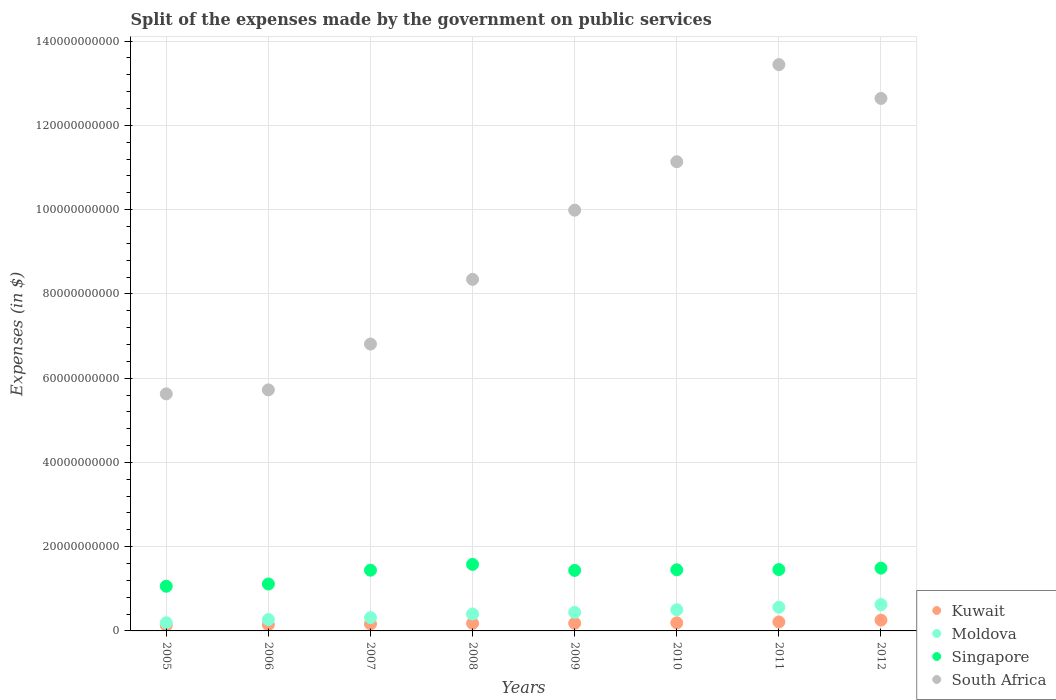Is the number of dotlines equal to the number of legend labels?
Keep it short and to the point. Yes. What is the expenses made by the government on public services in South Africa in 2005?
Provide a succinct answer. 5.63e+1. Across all years, what is the maximum expenses made by the government on public services in South Africa?
Provide a short and direct response. 1.34e+11. Across all years, what is the minimum expenses made by the government on public services in Kuwait?
Ensure brevity in your answer.  1.35e+09. In which year was the expenses made by the government on public services in Moldova maximum?
Your answer should be compact. 2012. In which year was the expenses made by the government on public services in Singapore minimum?
Offer a terse response. 2005. What is the total expenses made by the government on public services in South Africa in the graph?
Offer a very short reply. 7.37e+11. What is the difference between the expenses made by the government on public services in Moldova in 2007 and that in 2009?
Offer a very short reply. -1.26e+09. What is the difference between the expenses made by the government on public services in Kuwait in 2005 and the expenses made by the government on public services in Moldova in 2008?
Offer a very short reply. -2.67e+09. What is the average expenses made by the government on public services in Singapore per year?
Give a very brief answer. 1.38e+1. In the year 2011, what is the difference between the expenses made by the government on public services in South Africa and expenses made by the government on public services in Kuwait?
Offer a terse response. 1.32e+11. What is the ratio of the expenses made by the government on public services in South Africa in 2008 to that in 2009?
Your response must be concise. 0.84. Is the expenses made by the government on public services in Singapore in 2008 less than that in 2009?
Provide a succinct answer. No. What is the difference between the highest and the second highest expenses made by the government on public services in Moldova?
Give a very brief answer. 6.26e+08. What is the difference between the highest and the lowest expenses made by the government on public services in South Africa?
Offer a very short reply. 7.82e+1. In how many years, is the expenses made by the government on public services in Kuwait greater than the average expenses made by the government on public services in Kuwait taken over all years?
Make the answer very short. 3. Does the expenses made by the government on public services in Kuwait monotonically increase over the years?
Offer a terse response. Yes. Is the expenses made by the government on public services in Moldova strictly greater than the expenses made by the government on public services in Singapore over the years?
Offer a very short reply. No. Is the expenses made by the government on public services in Singapore strictly less than the expenses made by the government on public services in Moldova over the years?
Your answer should be compact. No. How many dotlines are there?
Offer a terse response. 4. Are the values on the major ticks of Y-axis written in scientific E-notation?
Your answer should be very brief. No. Does the graph contain any zero values?
Your answer should be compact. No. What is the title of the graph?
Provide a succinct answer. Split of the expenses made by the government on public services. Does "Cuba" appear as one of the legend labels in the graph?
Your answer should be very brief. No. What is the label or title of the X-axis?
Ensure brevity in your answer.  Years. What is the label or title of the Y-axis?
Your response must be concise. Expenses (in $). What is the Expenses (in $) in Kuwait in 2005?
Provide a succinct answer. 1.35e+09. What is the Expenses (in $) of Moldova in 2005?
Offer a very short reply. 1.94e+09. What is the Expenses (in $) in Singapore in 2005?
Provide a succinct answer. 1.06e+1. What is the Expenses (in $) of South Africa in 2005?
Give a very brief answer. 5.63e+1. What is the Expenses (in $) in Kuwait in 2006?
Your answer should be compact. 1.47e+09. What is the Expenses (in $) of Moldova in 2006?
Ensure brevity in your answer.  2.70e+09. What is the Expenses (in $) in Singapore in 2006?
Provide a short and direct response. 1.11e+1. What is the Expenses (in $) of South Africa in 2006?
Your answer should be compact. 5.72e+1. What is the Expenses (in $) in Kuwait in 2007?
Provide a short and direct response. 1.66e+09. What is the Expenses (in $) of Moldova in 2007?
Your answer should be compact. 3.15e+09. What is the Expenses (in $) in Singapore in 2007?
Make the answer very short. 1.44e+1. What is the Expenses (in $) in South Africa in 2007?
Keep it short and to the point. 6.81e+1. What is the Expenses (in $) in Kuwait in 2008?
Keep it short and to the point. 1.79e+09. What is the Expenses (in $) in Moldova in 2008?
Keep it short and to the point. 4.02e+09. What is the Expenses (in $) in Singapore in 2008?
Give a very brief answer. 1.58e+1. What is the Expenses (in $) of South Africa in 2008?
Give a very brief answer. 8.35e+1. What is the Expenses (in $) in Kuwait in 2009?
Make the answer very short. 1.82e+09. What is the Expenses (in $) in Moldova in 2009?
Your response must be concise. 4.41e+09. What is the Expenses (in $) in Singapore in 2009?
Ensure brevity in your answer.  1.44e+1. What is the Expenses (in $) in South Africa in 2009?
Provide a short and direct response. 9.99e+1. What is the Expenses (in $) of Kuwait in 2010?
Keep it short and to the point. 1.92e+09. What is the Expenses (in $) of Moldova in 2010?
Make the answer very short. 5.03e+09. What is the Expenses (in $) of Singapore in 2010?
Your response must be concise. 1.45e+1. What is the Expenses (in $) in South Africa in 2010?
Provide a succinct answer. 1.11e+11. What is the Expenses (in $) in Kuwait in 2011?
Keep it short and to the point. 2.13e+09. What is the Expenses (in $) of Moldova in 2011?
Your answer should be compact. 5.63e+09. What is the Expenses (in $) of Singapore in 2011?
Your response must be concise. 1.46e+1. What is the Expenses (in $) in South Africa in 2011?
Provide a succinct answer. 1.34e+11. What is the Expenses (in $) of Kuwait in 2012?
Your response must be concise. 2.56e+09. What is the Expenses (in $) in Moldova in 2012?
Make the answer very short. 6.25e+09. What is the Expenses (in $) of Singapore in 2012?
Provide a short and direct response. 1.49e+1. What is the Expenses (in $) in South Africa in 2012?
Offer a terse response. 1.26e+11. Across all years, what is the maximum Expenses (in $) in Kuwait?
Provide a succinct answer. 2.56e+09. Across all years, what is the maximum Expenses (in $) of Moldova?
Offer a very short reply. 6.25e+09. Across all years, what is the maximum Expenses (in $) of Singapore?
Provide a short and direct response. 1.58e+1. Across all years, what is the maximum Expenses (in $) of South Africa?
Your response must be concise. 1.34e+11. Across all years, what is the minimum Expenses (in $) in Kuwait?
Your answer should be very brief. 1.35e+09. Across all years, what is the minimum Expenses (in $) of Moldova?
Offer a very short reply. 1.94e+09. Across all years, what is the minimum Expenses (in $) of Singapore?
Provide a short and direct response. 1.06e+1. Across all years, what is the minimum Expenses (in $) of South Africa?
Keep it short and to the point. 5.63e+1. What is the total Expenses (in $) in Kuwait in the graph?
Give a very brief answer. 1.47e+1. What is the total Expenses (in $) in Moldova in the graph?
Your response must be concise. 3.31e+1. What is the total Expenses (in $) of Singapore in the graph?
Your answer should be very brief. 1.10e+11. What is the total Expenses (in $) of South Africa in the graph?
Offer a very short reply. 7.37e+11. What is the difference between the Expenses (in $) in Kuwait in 2005 and that in 2006?
Make the answer very short. -1.22e+08. What is the difference between the Expenses (in $) in Moldova in 2005 and that in 2006?
Offer a terse response. -7.68e+08. What is the difference between the Expenses (in $) in Singapore in 2005 and that in 2006?
Make the answer very short. -5.39e+08. What is the difference between the Expenses (in $) in South Africa in 2005 and that in 2006?
Provide a short and direct response. -9.39e+08. What is the difference between the Expenses (in $) of Kuwait in 2005 and that in 2007?
Your response must be concise. -3.08e+08. What is the difference between the Expenses (in $) of Moldova in 2005 and that in 2007?
Ensure brevity in your answer.  -1.21e+09. What is the difference between the Expenses (in $) in Singapore in 2005 and that in 2007?
Provide a short and direct response. -3.81e+09. What is the difference between the Expenses (in $) of South Africa in 2005 and that in 2007?
Your response must be concise. -1.18e+1. What is the difference between the Expenses (in $) in Kuwait in 2005 and that in 2008?
Offer a terse response. -4.40e+08. What is the difference between the Expenses (in $) in Moldova in 2005 and that in 2008?
Your answer should be very brief. -2.08e+09. What is the difference between the Expenses (in $) of Singapore in 2005 and that in 2008?
Ensure brevity in your answer.  -5.19e+09. What is the difference between the Expenses (in $) in South Africa in 2005 and that in 2008?
Give a very brief answer. -2.72e+1. What is the difference between the Expenses (in $) of Kuwait in 2005 and that in 2009?
Keep it short and to the point. -4.72e+08. What is the difference between the Expenses (in $) in Moldova in 2005 and that in 2009?
Your response must be concise. -2.47e+09. What is the difference between the Expenses (in $) of Singapore in 2005 and that in 2009?
Your answer should be compact. -3.76e+09. What is the difference between the Expenses (in $) in South Africa in 2005 and that in 2009?
Make the answer very short. -4.36e+1. What is the difference between the Expenses (in $) in Kuwait in 2005 and that in 2010?
Keep it short and to the point. -5.70e+08. What is the difference between the Expenses (in $) in Moldova in 2005 and that in 2010?
Offer a very short reply. -3.10e+09. What is the difference between the Expenses (in $) of Singapore in 2005 and that in 2010?
Make the answer very short. -3.91e+09. What is the difference between the Expenses (in $) in South Africa in 2005 and that in 2010?
Your answer should be compact. -5.51e+1. What is the difference between the Expenses (in $) of Kuwait in 2005 and that in 2011?
Your answer should be very brief. -7.79e+08. What is the difference between the Expenses (in $) of Moldova in 2005 and that in 2011?
Your answer should be very brief. -3.69e+09. What is the difference between the Expenses (in $) in Singapore in 2005 and that in 2011?
Ensure brevity in your answer.  -3.96e+09. What is the difference between the Expenses (in $) of South Africa in 2005 and that in 2011?
Give a very brief answer. -7.82e+1. What is the difference between the Expenses (in $) in Kuwait in 2005 and that in 2012?
Offer a very short reply. -1.21e+09. What is the difference between the Expenses (in $) of Moldova in 2005 and that in 2012?
Give a very brief answer. -4.32e+09. What is the difference between the Expenses (in $) in Singapore in 2005 and that in 2012?
Keep it short and to the point. -4.30e+09. What is the difference between the Expenses (in $) in South Africa in 2005 and that in 2012?
Keep it short and to the point. -7.01e+1. What is the difference between the Expenses (in $) of Kuwait in 2006 and that in 2007?
Provide a short and direct response. -1.86e+08. What is the difference between the Expenses (in $) in Moldova in 2006 and that in 2007?
Offer a terse response. -4.45e+08. What is the difference between the Expenses (in $) of Singapore in 2006 and that in 2007?
Offer a very short reply. -3.27e+09. What is the difference between the Expenses (in $) in South Africa in 2006 and that in 2007?
Provide a short and direct response. -1.09e+1. What is the difference between the Expenses (in $) in Kuwait in 2006 and that in 2008?
Ensure brevity in your answer.  -3.18e+08. What is the difference between the Expenses (in $) in Moldova in 2006 and that in 2008?
Offer a terse response. -1.31e+09. What is the difference between the Expenses (in $) in Singapore in 2006 and that in 2008?
Your answer should be very brief. -4.65e+09. What is the difference between the Expenses (in $) in South Africa in 2006 and that in 2008?
Provide a succinct answer. -2.62e+1. What is the difference between the Expenses (in $) of Kuwait in 2006 and that in 2009?
Provide a succinct answer. -3.50e+08. What is the difference between the Expenses (in $) in Moldova in 2006 and that in 2009?
Provide a short and direct response. -1.70e+09. What is the difference between the Expenses (in $) in Singapore in 2006 and that in 2009?
Make the answer very short. -3.22e+09. What is the difference between the Expenses (in $) in South Africa in 2006 and that in 2009?
Your response must be concise. -4.27e+1. What is the difference between the Expenses (in $) of Kuwait in 2006 and that in 2010?
Give a very brief answer. -4.48e+08. What is the difference between the Expenses (in $) in Moldova in 2006 and that in 2010?
Offer a terse response. -2.33e+09. What is the difference between the Expenses (in $) in Singapore in 2006 and that in 2010?
Give a very brief answer. -3.37e+09. What is the difference between the Expenses (in $) in South Africa in 2006 and that in 2010?
Give a very brief answer. -5.42e+1. What is the difference between the Expenses (in $) in Kuwait in 2006 and that in 2011?
Provide a short and direct response. -6.57e+08. What is the difference between the Expenses (in $) of Moldova in 2006 and that in 2011?
Give a very brief answer. -2.92e+09. What is the difference between the Expenses (in $) of Singapore in 2006 and that in 2011?
Your answer should be very brief. -3.42e+09. What is the difference between the Expenses (in $) of South Africa in 2006 and that in 2011?
Offer a very short reply. -7.72e+1. What is the difference between the Expenses (in $) of Kuwait in 2006 and that in 2012?
Keep it short and to the point. -1.09e+09. What is the difference between the Expenses (in $) in Moldova in 2006 and that in 2012?
Your response must be concise. -3.55e+09. What is the difference between the Expenses (in $) in Singapore in 2006 and that in 2012?
Offer a very short reply. -3.76e+09. What is the difference between the Expenses (in $) of South Africa in 2006 and that in 2012?
Your answer should be compact. -6.92e+1. What is the difference between the Expenses (in $) in Kuwait in 2007 and that in 2008?
Make the answer very short. -1.32e+08. What is the difference between the Expenses (in $) in Moldova in 2007 and that in 2008?
Offer a terse response. -8.67e+08. What is the difference between the Expenses (in $) in Singapore in 2007 and that in 2008?
Provide a short and direct response. -1.38e+09. What is the difference between the Expenses (in $) of South Africa in 2007 and that in 2008?
Ensure brevity in your answer.  -1.54e+1. What is the difference between the Expenses (in $) in Kuwait in 2007 and that in 2009?
Provide a succinct answer. -1.64e+08. What is the difference between the Expenses (in $) of Moldova in 2007 and that in 2009?
Make the answer very short. -1.26e+09. What is the difference between the Expenses (in $) of Singapore in 2007 and that in 2009?
Offer a very short reply. 4.70e+07. What is the difference between the Expenses (in $) in South Africa in 2007 and that in 2009?
Ensure brevity in your answer.  -3.18e+1. What is the difference between the Expenses (in $) of Kuwait in 2007 and that in 2010?
Your answer should be compact. -2.62e+08. What is the difference between the Expenses (in $) in Moldova in 2007 and that in 2010?
Keep it short and to the point. -1.88e+09. What is the difference between the Expenses (in $) in Singapore in 2007 and that in 2010?
Offer a very short reply. -9.78e+07. What is the difference between the Expenses (in $) in South Africa in 2007 and that in 2010?
Make the answer very short. -4.33e+1. What is the difference between the Expenses (in $) in Kuwait in 2007 and that in 2011?
Offer a terse response. -4.71e+08. What is the difference between the Expenses (in $) in Moldova in 2007 and that in 2011?
Your response must be concise. -2.48e+09. What is the difference between the Expenses (in $) of Singapore in 2007 and that in 2011?
Give a very brief answer. -1.50e+08. What is the difference between the Expenses (in $) of South Africa in 2007 and that in 2011?
Give a very brief answer. -6.63e+1. What is the difference between the Expenses (in $) in Kuwait in 2007 and that in 2012?
Give a very brief answer. -9.04e+08. What is the difference between the Expenses (in $) in Moldova in 2007 and that in 2012?
Provide a short and direct response. -3.10e+09. What is the difference between the Expenses (in $) in Singapore in 2007 and that in 2012?
Ensure brevity in your answer.  -4.86e+08. What is the difference between the Expenses (in $) in South Africa in 2007 and that in 2012?
Your answer should be compact. -5.83e+1. What is the difference between the Expenses (in $) in Kuwait in 2008 and that in 2009?
Make the answer very short. -3.20e+07. What is the difference between the Expenses (in $) of Moldova in 2008 and that in 2009?
Offer a very short reply. -3.88e+08. What is the difference between the Expenses (in $) in Singapore in 2008 and that in 2009?
Your response must be concise. 1.42e+09. What is the difference between the Expenses (in $) in South Africa in 2008 and that in 2009?
Provide a succinct answer. -1.64e+1. What is the difference between the Expenses (in $) in Kuwait in 2008 and that in 2010?
Give a very brief answer. -1.30e+08. What is the difference between the Expenses (in $) of Moldova in 2008 and that in 2010?
Keep it short and to the point. -1.02e+09. What is the difference between the Expenses (in $) in Singapore in 2008 and that in 2010?
Provide a short and direct response. 1.28e+09. What is the difference between the Expenses (in $) of South Africa in 2008 and that in 2010?
Give a very brief answer. -2.79e+1. What is the difference between the Expenses (in $) of Kuwait in 2008 and that in 2011?
Your answer should be very brief. -3.39e+08. What is the difference between the Expenses (in $) of Moldova in 2008 and that in 2011?
Provide a succinct answer. -1.61e+09. What is the difference between the Expenses (in $) of Singapore in 2008 and that in 2011?
Keep it short and to the point. 1.23e+09. What is the difference between the Expenses (in $) of South Africa in 2008 and that in 2011?
Give a very brief answer. -5.10e+1. What is the difference between the Expenses (in $) of Kuwait in 2008 and that in 2012?
Ensure brevity in your answer.  -7.72e+08. What is the difference between the Expenses (in $) in Moldova in 2008 and that in 2012?
Make the answer very short. -2.24e+09. What is the difference between the Expenses (in $) of Singapore in 2008 and that in 2012?
Your response must be concise. 8.91e+08. What is the difference between the Expenses (in $) in South Africa in 2008 and that in 2012?
Give a very brief answer. -4.29e+1. What is the difference between the Expenses (in $) in Kuwait in 2009 and that in 2010?
Give a very brief answer. -9.80e+07. What is the difference between the Expenses (in $) in Moldova in 2009 and that in 2010?
Your response must be concise. -6.28e+08. What is the difference between the Expenses (in $) in Singapore in 2009 and that in 2010?
Keep it short and to the point. -1.45e+08. What is the difference between the Expenses (in $) of South Africa in 2009 and that in 2010?
Your response must be concise. -1.15e+1. What is the difference between the Expenses (in $) in Kuwait in 2009 and that in 2011?
Offer a terse response. -3.07e+08. What is the difference between the Expenses (in $) in Moldova in 2009 and that in 2011?
Keep it short and to the point. -1.22e+09. What is the difference between the Expenses (in $) of Singapore in 2009 and that in 2011?
Offer a very short reply. -1.97e+08. What is the difference between the Expenses (in $) in South Africa in 2009 and that in 2011?
Provide a succinct answer. -3.46e+1. What is the difference between the Expenses (in $) of Kuwait in 2009 and that in 2012?
Make the answer very short. -7.40e+08. What is the difference between the Expenses (in $) in Moldova in 2009 and that in 2012?
Provide a short and direct response. -1.85e+09. What is the difference between the Expenses (in $) of Singapore in 2009 and that in 2012?
Your answer should be very brief. -5.33e+08. What is the difference between the Expenses (in $) in South Africa in 2009 and that in 2012?
Provide a short and direct response. -2.65e+1. What is the difference between the Expenses (in $) in Kuwait in 2010 and that in 2011?
Your response must be concise. -2.09e+08. What is the difference between the Expenses (in $) in Moldova in 2010 and that in 2011?
Your answer should be very brief. -5.93e+08. What is the difference between the Expenses (in $) of Singapore in 2010 and that in 2011?
Keep it short and to the point. -5.24e+07. What is the difference between the Expenses (in $) in South Africa in 2010 and that in 2011?
Provide a succinct answer. -2.31e+1. What is the difference between the Expenses (in $) of Kuwait in 2010 and that in 2012?
Ensure brevity in your answer.  -6.42e+08. What is the difference between the Expenses (in $) in Moldova in 2010 and that in 2012?
Keep it short and to the point. -1.22e+09. What is the difference between the Expenses (in $) of Singapore in 2010 and that in 2012?
Provide a succinct answer. -3.88e+08. What is the difference between the Expenses (in $) of South Africa in 2010 and that in 2012?
Your answer should be very brief. -1.50e+1. What is the difference between the Expenses (in $) in Kuwait in 2011 and that in 2012?
Offer a terse response. -4.33e+08. What is the difference between the Expenses (in $) of Moldova in 2011 and that in 2012?
Your answer should be compact. -6.26e+08. What is the difference between the Expenses (in $) of Singapore in 2011 and that in 2012?
Make the answer very short. -3.36e+08. What is the difference between the Expenses (in $) of South Africa in 2011 and that in 2012?
Provide a short and direct response. 8.03e+09. What is the difference between the Expenses (in $) of Kuwait in 2005 and the Expenses (in $) of Moldova in 2006?
Your answer should be very brief. -1.35e+09. What is the difference between the Expenses (in $) in Kuwait in 2005 and the Expenses (in $) in Singapore in 2006?
Offer a very short reply. -9.79e+09. What is the difference between the Expenses (in $) in Kuwait in 2005 and the Expenses (in $) in South Africa in 2006?
Your response must be concise. -5.59e+1. What is the difference between the Expenses (in $) in Moldova in 2005 and the Expenses (in $) in Singapore in 2006?
Give a very brief answer. -9.21e+09. What is the difference between the Expenses (in $) in Moldova in 2005 and the Expenses (in $) in South Africa in 2006?
Make the answer very short. -5.53e+1. What is the difference between the Expenses (in $) in Singapore in 2005 and the Expenses (in $) in South Africa in 2006?
Ensure brevity in your answer.  -4.66e+1. What is the difference between the Expenses (in $) in Kuwait in 2005 and the Expenses (in $) in Moldova in 2007?
Keep it short and to the point. -1.80e+09. What is the difference between the Expenses (in $) of Kuwait in 2005 and the Expenses (in $) of Singapore in 2007?
Your answer should be very brief. -1.31e+1. What is the difference between the Expenses (in $) in Kuwait in 2005 and the Expenses (in $) in South Africa in 2007?
Offer a terse response. -6.67e+1. What is the difference between the Expenses (in $) in Moldova in 2005 and the Expenses (in $) in Singapore in 2007?
Your response must be concise. -1.25e+1. What is the difference between the Expenses (in $) of Moldova in 2005 and the Expenses (in $) of South Africa in 2007?
Your answer should be compact. -6.62e+1. What is the difference between the Expenses (in $) in Singapore in 2005 and the Expenses (in $) in South Africa in 2007?
Provide a short and direct response. -5.75e+1. What is the difference between the Expenses (in $) of Kuwait in 2005 and the Expenses (in $) of Moldova in 2008?
Your response must be concise. -2.67e+09. What is the difference between the Expenses (in $) in Kuwait in 2005 and the Expenses (in $) in Singapore in 2008?
Provide a short and direct response. -1.44e+1. What is the difference between the Expenses (in $) in Kuwait in 2005 and the Expenses (in $) in South Africa in 2008?
Your answer should be compact. -8.21e+1. What is the difference between the Expenses (in $) in Moldova in 2005 and the Expenses (in $) in Singapore in 2008?
Provide a succinct answer. -1.39e+1. What is the difference between the Expenses (in $) of Moldova in 2005 and the Expenses (in $) of South Africa in 2008?
Provide a succinct answer. -8.15e+1. What is the difference between the Expenses (in $) of Singapore in 2005 and the Expenses (in $) of South Africa in 2008?
Ensure brevity in your answer.  -7.29e+1. What is the difference between the Expenses (in $) of Kuwait in 2005 and the Expenses (in $) of Moldova in 2009?
Give a very brief answer. -3.05e+09. What is the difference between the Expenses (in $) of Kuwait in 2005 and the Expenses (in $) of Singapore in 2009?
Provide a succinct answer. -1.30e+1. What is the difference between the Expenses (in $) of Kuwait in 2005 and the Expenses (in $) of South Africa in 2009?
Your response must be concise. -9.85e+1. What is the difference between the Expenses (in $) in Moldova in 2005 and the Expenses (in $) in Singapore in 2009?
Offer a terse response. -1.24e+1. What is the difference between the Expenses (in $) of Moldova in 2005 and the Expenses (in $) of South Africa in 2009?
Provide a short and direct response. -9.79e+1. What is the difference between the Expenses (in $) of Singapore in 2005 and the Expenses (in $) of South Africa in 2009?
Make the answer very short. -8.93e+1. What is the difference between the Expenses (in $) of Kuwait in 2005 and the Expenses (in $) of Moldova in 2010?
Offer a very short reply. -3.68e+09. What is the difference between the Expenses (in $) of Kuwait in 2005 and the Expenses (in $) of Singapore in 2010?
Your answer should be compact. -1.32e+1. What is the difference between the Expenses (in $) in Kuwait in 2005 and the Expenses (in $) in South Africa in 2010?
Ensure brevity in your answer.  -1.10e+11. What is the difference between the Expenses (in $) of Moldova in 2005 and the Expenses (in $) of Singapore in 2010?
Give a very brief answer. -1.26e+1. What is the difference between the Expenses (in $) of Moldova in 2005 and the Expenses (in $) of South Africa in 2010?
Make the answer very short. -1.09e+11. What is the difference between the Expenses (in $) in Singapore in 2005 and the Expenses (in $) in South Africa in 2010?
Make the answer very short. -1.01e+11. What is the difference between the Expenses (in $) of Kuwait in 2005 and the Expenses (in $) of Moldova in 2011?
Give a very brief answer. -4.28e+09. What is the difference between the Expenses (in $) of Kuwait in 2005 and the Expenses (in $) of Singapore in 2011?
Ensure brevity in your answer.  -1.32e+1. What is the difference between the Expenses (in $) in Kuwait in 2005 and the Expenses (in $) in South Africa in 2011?
Give a very brief answer. -1.33e+11. What is the difference between the Expenses (in $) in Moldova in 2005 and the Expenses (in $) in Singapore in 2011?
Make the answer very short. -1.26e+1. What is the difference between the Expenses (in $) in Moldova in 2005 and the Expenses (in $) in South Africa in 2011?
Offer a terse response. -1.32e+11. What is the difference between the Expenses (in $) of Singapore in 2005 and the Expenses (in $) of South Africa in 2011?
Provide a succinct answer. -1.24e+11. What is the difference between the Expenses (in $) in Kuwait in 2005 and the Expenses (in $) in Moldova in 2012?
Keep it short and to the point. -4.90e+09. What is the difference between the Expenses (in $) of Kuwait in 2005 and the Expenses (in $) of Singapore in 2012?
Give a very brief answer. -1.35e+1. What is the difference between the Expenses (in $) in Kuwait in 2005 and the Expenses (in $) in South Africa in 2012?
Ensure brevity in your answer.  -1.25e+11. What is the difference between the Expenses (in $) of Moldova in 2005 and the Expenses (in $) of Singapore in 2012?
Your response must be concise. -1.30e+1. What is the difference between the Expenses (in $) of Moldova in 2005 and the Expenses (in $) of South Africa in 2012?
Give a very brief answer. -1.24e+11. What is the difference between the Expenses (in $) in Singapore in 2005 and the Expenses (in $) in South Africa in 2012?
Make the answer very short. -1.16e+11. What is the difference between the Expenses (in $) in Kuwait in 2006 and the Expenses (in $) in Moldova in 2007?
Offer a very short reply. -1.68e+09. What is the difference between the Expenses (in $) of Kuwait in 2006 and the Expenses (in $) of Singapore in 2007?
Your answer should be very brief. -1.29e+1. What is the difference between the Expenses (in $) in Kuwait in 2006 and the Expenses (in $) in South Africa in 2007?
Offer a very short reply. -6.66e+1. What is the difference between the Expenses (in $) of Moldova in 2006 and the Expenses (in $) of Singapore in 2007?
Offer a terse response. -1.17e+1. What is the difference between the Expenses (in $) in Moldova in 2006 and the Expenses (in $) in South Africa in 2007?
Offer a very short reply. -6.54e+1. What is the difference between the Expenses (in $) in Singapore in 2006 and the Expenses (in $) in South Africa in 2007?
Your answer should be compact. -5.70e+1. What is the difference between the Expenses (in $) of Kuwait in 2006 and the Expenses (in $) of Moldova in 2008?
Give a very brief answer. -2.54e+09. What is the difference between the Expenses (in $) of Kuwait in 2006 and the Expenses (in $) of Singapore in 2008?
Your response must be concise. -1.43e+1. What is the difference between the Expenses (in $) of Kuwait in 2006 and the Expenses (in $) of South Africa in 2008?
Give a very brief answer. -8.20e+1. What is the difference between the Expenses (in $) of Moldova in 2006 and the Expenses (in $) of Singapore in 2008?
Your answer should be compact. -1.31e+1. What is the difference between the Expenses (in $) in Moldova in 2006 and the Expenses (in $) in South Africa in 2008?
Give a very brief answer. -8.08e+1. What is the difference between the Expenses (in $) of Singapore in 2006 and the Expenses (in $) of South Africa in 2008?
Provide a succinct answer. -7.23e+1. What is the difference between the Expenses (in $) of Kuwait in 2006 and the Expenses (in $) of Moldova in 2009?
Offer a very short reply. -2.93e+09. What is the difference between the Expenses (in $) in Kuwait in 2006 and the Expenses (in $) in Singapore in 2009?
Your answer should be compact. -1.29e+1. What is the difference between the Expenses (in $) of Kuwait in 2006 and the Expenses (in $) of South Africa in 2009?
Keep it short and to the point. -9.84e+1. What is the difference between the Expenses (in $) in Moldova in 2006 and the Expenses (in $) in Singapore in 2009?
Offer a very short reply. -1.17e+1. What is the difference between the Expenses (in $) in Moldova in 2006 and the Expenses (in $) in South Africa in 2009?
Your response must be concise. -9.72e+1. What is the difference between the Expenses (in $) of Singapore in 2006 and the Expenses (in $) of South Africa in 2009?
Ensure brevity in your answer.  -8.87e+1. What is the difference between the Expenses (in $) of Kuwait in 2006 and the Expenses (in $) of Moldova in 2010?
Provide a short and direct response. -3.56e+09. What is the difference between the Expenses (in $) of Kuwait in 2006 and the Expenses (in $) of Singapore in 2010?
Offer a very short reply. -1.30e+1. What is the difference between the Expenses (in $) of Kuwait in 2006 and the Expenses (in $) of South Africa in 2010?
Provide a succinct answer. -1.10e+11. What is the difference between the Expenses (in $) in Moldova in 2006 and the Expenses (in $) in Singapore in 2010?
Your answer should be very brief. -1.18e+1. What is the difference between the Expenses (in $) of Moldova in 2006 and the Expenses (in $) of South Africa in 2010?
Your answer should be compact. -1.09e+11. What is the difference between the Expenses (in $) in Singapore in 2006 and the Expenses (in $) in South Africa in 2010?
Ensure brevity in your answer.  -1.00e+11. What is the difference between the Expenses (in $) in Kuwait in 2006 and the Expenses (in $) in Moldova in 2011?
Your answer should be compact. -4.15e+09. What is the difference between the Expenses (in $) in Kuwait in 2006 and the Expenses (in $) in Singapore in 2011?
Provide a succinct answer. -1.31e+1. What is the difference between the Expenses (in $) in Kuwait in 2006 and the Expenses (in $) in South Africa in 2011?
Offer a very short reply. -1.33e+11. What is the difference between the Expenses (in $) of Moldova in 2006 and the Expenses (in $) of Singapore in 2011?
Make the answer very short. -1.19e+1. What is the difference between the Expenses (in $) of Moldova in 2006 and the Expenses (in $) of South Africa in 2011?
Provide a short and direct response. -1.32e+11. What is the difference between the Expenses (in $) in Singapore in 2006 and the Expenses (in $) in South Africa in 2011?
Offer a terse response. -1.23e+11. What is the difference between the Expenses (in $) in Kuwait in 2006 and the Expenses (in $) in Moldova in 2012?
Your answer should be very brief. -4.78e+09. What is the difference between the Expenses (in $) of Kuwait in 2006 and the Expenses (in $) of Singapore in 2012?
Make the answer very short. -1.34e+1. What is the difference between the Expenses (in $) in Kuwait in 2006 and the Expenses (in $) in South Africa in 2012?
Your answer should be very brief. -1.25e+11. What is the difference between the Expenses (in $) of Moldova in 2006 and the Expenses (in $) of Singapore in 2012?
Provide a short and direct response. -1.22e+1. What is the difference between the Expenses (in $) of Moldova in 2006 and the Expenses (in $) of South Africa in 2012?
Provide a short and direct response. -1.24e+11. What is the difference between the Expenses (in $) of Singapore in 2006 and the Expenses (in $) of South Africa in 2012?
Ensure brevity in your answer.  -1.15e+11. What is the difference between the Expenses (in $) in Kuwait in 2007 and the Expenses (in $) in Moldova in 2008?
Offer a very short reply. -2.36e+09. What is the difference between the Expenses (in $) in Kuwait in 2007 and the Expenses (in $) in Singapore in 2008?
Your response must be concise. -1.41e+1. What is the difference between the Expenses (in $) in Kuwait in 2007 and the Expenses (in $) in South Africa in 2008?
Make the answer very short. -8.18e+1. What is the difference between the Expenses (in $) in Moldova in 2007 and the Expenses (in $) in Singapore in 2008?
Provide a short and direct response. -1.26e+1. What is the difference between the Expenses (in $) of Moldova in 2007 and the Expenses (in $) of South Africa in 2008?
Provide a succinct answer. -8.03e+1. What is the difference between the Expenses (in $) in Singapore in 2007 and the Expenses (in $) in South Africa in 2008?
Offer a terse response. -6.90e+1. What is the difference between the Expenses (in $) in Kuwait in 2007 and the Expenses (in $) in Moldova in 2009?
Provide a short and direct response. -2.75e+09. What is the difference between the Expenses (in $) in Kuwait in 2007 and the Expenses (in $) in Singapore in 2009?
Make the answer very short. -1.27e+1. What is the difference between the Expenses (in $) of Kuwait in 2007 and the Expenses (in $) of South Africa in 2009?
Provide a short and direct response. -9.82e+1. What is the difference between the Expenses (in $) in Moldova in 2007 and the Expenses (in $) in Singapore in 2009?
Your answer should be compact. -1.12e+1. What is the difference between the Expenses (in $) in Moldova in 2007 and the Expenses (in $) in South Africa in 2009?
Offer a terse response. -9.67e+1. What is the difference between the Expenses (in $) of Singapore in 2007 and the Expenses (in $) of South Africa in 2009?
Your answer should be very brief. -8.55e+1. What is the difference between the Expenses (in $) of Kuwait in 2007 and the Expenses (in $) of Moldova in 2010?
Your answer should be compact. -3.37e+09. What is the difference between the Expenses (in $) of Kuwait in 2007 and the Expenses (in $) of Singapore in 2010?
Provide a succinct answer. -1.29e+1. What is the difference between the Expenses (in $) in Kuwait in 2007 and the Expenses (in $) in South Africa in 2010?
Offer a very short reply. -1.10e+11. What is the difference between the Expenses (in $) of Moldova in 2007 and the Expenses (in $) of Singapore in 2010?
Make the answer very short. -1.14e+1. What is the difference between the Expenses (in $) of Moldova in 2007 and the Expenses (in $) of South Africa in 2010?
Your answer should be compact. -1.08e+11. What is the difference between the Expenses (in $) of Singapore in 2007 and the Expenses (in $) of South Africa in 2010?
Keep it short and to the point. -9.70e+1. What is the difference between the Expenses (in $) of Kuwait in 2007 and the Expenses (in $) of Moldova in 2011?
Keep it short and to the point. -3.97e+09. What is the difference between the Expenses (in $) in Kuwait in 2007 and the Expenses (in $) in Singapore in 2011?
Give a very brief answer. -1.29e+1. What is the difference between the Expenses (in $) of Kuwait in 2007 and the Expenses (in $) of South Africa in 2011?
Keep it short and to the point. -1.33e+11. What is the difference between the Expenses (in $) of Moldova in 2007 and the Expenses (in $) of Singapore in 2011?
Provide a short and direct response. -1.14e+1. What is the difference between the Expenses (in $) in Moldova in 2007 and the Expenses (in $) in South Africa in 2011?
Offer a very short reply. -1.31e+11. What is the difference between the Expenses (in $) in Singapore in 2007 and the Expenses (in $) in South Africa in 2011?
Ensure brevity in your answer.  -1.20e+11. What is the difference between the Expenses (in $) of Kuwait in 2007 and the Expenses (in $) of Moldova in 2012?
Offer a terse response. -4.59e+09. What is the difference between the Expenses (in $) of Kuwait in 2007 and the Expenses (in $) of Singapore in 2012?
Ensure brevity in your answer.  -1.32e+1. What is the difference between the Expenses (in $) of Kuwait in 2007 and the Expenses (in $) of South Africa in 2012?
Provide a short and direct response. -1.25e+11. What is the difference between the Expenses (in $) of Moldova in 2007 and the Expenses (in $) of Singapore in 2012?
Provide a succinct answer. -1.18e+1. What is the difference between the Expenses (in $) of Moldova in 2007 and the Expenses (in $) of South Africa in 2012?
Provide a succinct answer. -1.23e+11. What is the difference between the Expenses (in $) of Singapore in 2007 and the Expenses (in $) of South Africa in 2012?
Your answer should be compact. -1.12e+11. What is the difference between the Expenses (in $) of Kuwait in 2008 and the Expenses (in $) of Moldova in 2009?
Offer a terse response. -2.61e+09. What is the difference between the Expenses (in $) in Kuwait in 2008 and the Expenses (in $) in Singapore in 2009?
Keep it short and to the point. -1.26e+1. What is the difference between the Expenses (in $) in Kuwait in 2008 and the Expenses (in $) in South Africa in 2009?
Your response must be concise. -9.81e+1. What is the difference between the Expenses (in $) in Moldova in 2008 and the Expenses (in $) in Singapore in 2009?
Provide a short and direct response. -1.04e+1. What is the difference between the Expenses (in $) in Moldova in 2008 and the Expenses (in $) in South Africa in 2009?
Offer a very short reply. -9.59e+1. What is the difference between the Expenses (in $) of Singapore in 2008 and the Expenses (in $) of South Africa in 2009?
Ensure brevity in your answer.  -8.41e+1. What is the difference between the Expenses (in $) in Kuwait in 2008 and the Expenses (in $) in Moldova in 2010?
Your answer should be very brief. -3.24e+09. What is the difference between the Expenses (in $) in Kuwait in 2008 and the Expenses (in $) in Singapore in 2010?
Provide a short and direct response. -1.27e+1. What is the difference between the Expenses (in $) in Kuwait in 2008 and the Expenses (in $) in South Africa in 2010?
Provide a short and direct response. -1.10e+11. What is the difference between the Expenses (in $) in Moldova in 2008 and the Expenses (in $) in Singapore in 2010?
Ensure brevity in your answer.  -1.05e+1. What is the difference between the Expenses (in $) of Moldova in 2008 and the Expenses (in $) of South Africa in 2010?
Provide a short and direct response. -1.07e+11. What is the difference between the Expenses (in $) in Singapore in 2008 and the Expenses (in $) in South Africa in 2010?
Your answer should be very brief. -9.56e+1. What is the difference between the Expenses (in $) in Kuwait in 2008 and the Expenses (in $) in Moldova in 2011?
Offer a terse response. -3.84e+09. What is the difference between the Expenses (in $) in Kuwait in 2008 and the Expenses (in $) in Singapore in 2011?
Your response must be concise. -1.28e+1. What is the difference between the Expenses (in $) in Kuwait in 2008 and the Expenses (in $) in South Africa in 2011?
Offer a terse response. -1.33e+11. What is the difference between the Expenses (in $) in Moldova in 2008 and the Expenses (in $) in Singapore in 2011?
Make the answer very short. -1.05e+1. What is the difference between the Expenses (in $) of Moldova in 2008 and the Expenses (in $) of South Africa in 2011?
Your answer should be compact. -1.30e+11. What is the difference between the Expenses (in $) of Singapore in 2008 and the Expenses (in $) of South Africa in 2011?
Offer a very short reply. -1.19e+11. What is the difference between the Expenses (in $) in Kuwait in 2008 and the Expenses (in $) in Moldova in 2012?
Offer a very short reply. -4.46e+09. What is the difference between the Expenses (in $) of Kuwait in 2008 and the Expenses (in $) of Singapore in 2012?
Your response must be concise. -1.31e+1. What is the difference between the Expenses (in $) in Kuwait in 2008 and the Expenses (in $) in South Africa in 2012?
Offer a very short reply. -1.25e+11. What is the difference between the Expenses (in $) in Moldova in 2008 and the Expenses (in $) in Singapore in 2012?
Keep it short and to the point. -1.09e+1. What is the difference between the Expenses (in $) in Moldova in 2008 and the Expenses (in $) in South Africa in 2012?
Give a very brief answer. -1.22e+11. What is the difference between the Expenses (in $) in Singapore in 2008 and the Expenses (in $) in South Africa in 2012?
Your response must be concise. -1.11e+11. What is the difference between the Expenses (in $) of Kuwait in 2009 and the Expenses (in $) of Moldova in 2010?
Ensure brevity in your answer.  -3.21e+09. What is the difference between the Expenses (in $) in Kuwait in 2009 and the Expenses (in $) in Singapore in 2010?
Ensure brevity in your answer.  -1.27e+1. What is the difference between the Expenses (in $) in Kuwait in 2009 and the Expenses (in $) in South Africa in 2010?
Provide a succinct answer. -1.10e+11. What is the difference between the Expenses (in $) in Moldova in 2009 and the Expenses (in $) in Singapore in 2010?
Provide a short and direct response. -1.01e+1. What is the difference between the Expenses (in $) of Moldova in 2009 and the Expenses (in $) of South Africa in 2010?
Make the answer very short. -1.07e+11. What is the difference between the Expenses (in $) in Singapore in 2009 and the Expenses (in $) in South Africa in 2010?
Your answer should be compact. -9.70e+1. What is the difference between the Expenses (in $) in Kuwait in 2009 and the Expenses (in $) in Moldova in 2011?
Offer a very short reply. -3.80e+09. What is the difference between the Expenses (in $) in Kuwait in 2009 and the Expenses (in $) in Singapore in 2011?
Provide a succinct answer. -1.27e+1. What is the difference between the Expenses (in $) of Kuwait in 2009 and the Expenses (in $) of South Africa in 2011?
Provide a short and direct response. -1.33e+11. What is the difference between the Expenses (in $) in Moldova in 2009 and the Expenses (in $) in Singapore in 2011?
Provide a succinct answer. -1.02e+1. What is the difference between the Expenses (in $) of Moldova in 2009 and the Expenses (in $) of South Africa in 2011?
Your answer should be compact. -1.30e+11. What is the difference between the Expenses (in $) of Singapore in 2009 and the Expenses (in $) of South Africa in 2011?
Make the answer very short. -1.20e+11. What is the difference between the Expenses (in $) in Kuwait in 2009 and the Expenses (in $) in Moldova in 2012?
Your answer should be very brief. -4.43e+09. What is the difference between the Expenses (in $) of Kuwait in 2009 and the Expenses (in $) of Singapore in 2012?
Keep it short and to the point. -1.31e+1. What is the difference between the Expenses (in $) in Kuwait in 2009 and the Expenses (in $) in South Africa in 2012?
Offer a terse response. -1.25e+11. What is the difference between the Expenses (in $) in Moldova in 2009 and the Expenses (in $) in Singapore in 2012?
Give a very brief answer. -1.05e+1. What is the difference between the Expenses (in $) of Moldova in 2009 and the Expenses (in $) of South Africa in 2012?
Provide a short and direct response. -1.22e+11. What is the difference between the Expenses (in $) of Singapore in 2009 and the Expenses (in $) of South Africa in 2012?
Your answer should be compact. -1.12e+11. What is the difference between the Expenses (in $) in Kuwait in 2010 and the Expenses (in $) in Moldova in 2011?
Ensure brevity in your answer.  -3.71e+09. What is the difference between the Expenses (in $) of Kuwait in 2010 and the Expenses (in $) of Singapore in 2011?
Ensure brevity in your answer.  -1.26e+1. What is the difference between the Expenses (in $) of Kuwait in 2010 and the Expenses (in $) of South Africa in 2011?
Offer a terse response. -1.33e+11. What is the difference between the Expenses (in $) of Moldova in 2010 and the Expenses (in $) of Singapore in 2011?
Provide a short and direct response. -9.53e+09. What is the difference between the Expenses (in $) of Moldova in 2010 and the Expenses (in $) of South Africa in 2011?
Your answer should be very brief. -1.29e+11. What is the difference between the Expenses (in $) of Singapore in 2010 and the Expenses (in $) of South Africa in 2011?
Your answer should be compact. -1.20e+11. What is the difference between the Expenses (in $) in Kuwait in 2010 and the Expenses (in $) in Moldova in 2012?
Keep it short and to the point. -4.33e+09. What is the difference between the Expenses (in $) of Kuwait in 2010 and the Expenses (in $) of Singapore in 2012?
Keep it short and to the point. -1.30e+1. What is the difference between the Expenses (in $) in Kuwait in 2010 and the Expenses (in $) in South Africa in 2012?
Provide a succinct answer. -1.24e+11. What is the difference between the Expenses (in $) in Moldova in 2010 and the Expenses (in $) in Singapore in 2012?
Your response must be concise. -9.87e+09. What is the difference between the Expenses (in $) of Moldova in 2010 and the Expenses (in $) of South Africa in 2012?
Your answer should be compact. -1.21e+11. What is the difference between the Expenses (in $) of Singapore in 2010 and the Expenses (in $) of South Africa in 2012?
Provide a short and direct response. -1.12e+11. What is the difference between the Expenses (in $) of Kuwait in 2011 and the Expenses (in $) of Moldova in 2012?
Provide a succinct answer. -4.12e+09. What is the difference between the Expenses (in $) in Kuwait in 2011 and the Expenses (in $) in Singapore in 2012?
Offer a very short reply. -1.28e+1. What is the difference between the Expenses (in $) in Kuwait in 2011 and the Expenses (in $) in South Africa in 2012?
Give a very brief answer. -1.24e+11. What is the difference between the Expenses (in $) of Moldova in 2011 and the Expenses (in $) of Singapore in 2012?
Your answer should be compact. -9.27e+09. What is the difference between the Expenses (in $) of Moldova in 2011 and the Expenses (in $) of South Africa in 2012?
Offer a terse response. -1.21e+11. What is the difference between the Expenses (in $) of Singapore in 2011 and the Expenses (in $) of South Africa in 2012?
Your answer should be very brief. -1.12e+11. What is the average Expenses (in $) in Kuwait per year?
Offer a terse response. 1.84e+09. What is the average Expenses (in $) in Moldova per year?
Your answer should be very brief. 4.14e+09. What is the average Expenses (in $) of Singapore per year?
Offer a terse response. 1.38e+1. What is the average Expenses (in $) of South Africa per year?
Your answer should be compact. 9.21e+1. In the year 2005, what is the difference between the Expenses (in $) of Kuwait and Expenses (in $) of Moldova?
Your answer should be compact. -5.85e+08. In the year 2005, what is the difference between the Expenses (in $) in Kuwait and Expenses (in $) in Singapore?
Provide a short and direct response. -9.25e+09. In the year 2005, what is the difference between the Expenses (in $) of Kuwait and Expenses (in $) of South Africa?
Make the answer very short. -5.49e+1. In the year 2005, what is the difference between the Expenses (in $) of Moldova and Expenses (in $) of Singapore?
Give a very brief answer. -8.67e+09. In the year 2005, what is the difference between the Expenses (in $) of Moldova and Expenses (in $) of South Africa?
Keep it short and to the point. -5.43e+1. In the year 2005, what is the difference between the Expenses (in $) in Singapore and Expenses (in $) in South Africa?
Your answer should be compact. -4.57e+1. In the year 2006, what is the difference between the Expenses (in $) of Kuwait and Expenses (in $) of Moldova?
Provide a short and direct response. -1.23e+09. In the year 2006, what is the difference between the Expenses (in $) of Kuwait and Expenses (in $) of Singapore?
Your response must be concise. -9.67e+09. In the year 2006, what is the difference between the Expenses (in $) in Kuwait and Expenses (in $) in South Africa?
Your answer should be compact. -5.57e+1. In the year 2006, what is the difference between the Expenses (in $) of Moldova and Expenses (in $) of Singapore?
Ensure brevity in your answer.  -8.44e+09. In the year 2006, what is the difference between the Expenses (in $) of Moldova and Expenses (in $) of South Africa?
Ensure brevity in your answer.  -5.45e+1. In the year 2006, what is the difference between the Expenses (in $) in Singapore and Expenses (in $) in South Africa?
Your answer should be compact. -4.61e+1. In the year 2007, what is the difference between the Expenses (in $) of Kuwait and Expenses (in $) of Moldova?
Keep it short and to the point. -1.49e+09. In the year 2007, what is the difference between the Expenses (in $) of Kuwait and Expenses (in $) of Singapore?
Your answer should be very brief. -1.28e+1. In the year 2007, what is the difference between the Expenses (in $) in Kuwait and Expenses (in $) in South Africa?
Offer a terse response. -6.64e+1. In the year 2007, what is the difference between the Expenses (in $) of Moldova and Expenses (in $) of Singapore?
Give a very brief answer. -1.13e+1. In the year 2007, what is the difference between the Expenses (in $) in Moldova and Expenses (in $) in South Africa?
Your answer should be compact. -6.49e+1. In the year 2007, what is the difference between the Expenses (in $) of Singapore and Expenses (in $) of South Africa?
Your answer should be very brief. -5.37e+1. In the year 2008, what is the difference between the Expenses (in $) of Kuwait and Expenses (in $) of Moldova?
Provide a succinct answer. -2.23e+09. In the year 2008, what is the difference between the Expenses (in $) in Kuwait and Expenses (in $) in Singapore?
Your response must be concise. -1.40e+1. In the year 2008, what is the difference between the Expenses (in $) in Kuwait and Expenses (in $) in South Africa?
Keep it short and to the point. -8.17e+1. In the year 2008, what is the difference between the Expenses (in $) of Moldova and Expenses (in $) of Singapore?
Offer a very short reply. -1.18e+1. In the year 2008, what is the difference between the Expenses (in $) in Moldova and Expenses (in $) in South Africa?
Provide a succinct answer. -7.94e+1. In the year 2008, what is the difference between the Expenses (in $) of Singapore and Expenses (in $) of South Africa?
Make the answer very short. -6.77e+1. In the year 2009, what is the difference between the Expenses (in $) in Kuwait and Expenses (in $) in Moldova?
Offer a terse response. -2.58e+09. In the year 2009, what is the difference between the Expenses (in $) in Kuwait and Expenses (in $) in Singapore?
Make the answer very short. -1.25e+1. In the year 2009, what is the difference between the Expenses (in $) in Kuwait and Expenses (in $) in South Africa?
Provide a succinct answer. -9.81e+1. In the year 2009, what is the difference between the Expenses (in $) of Moldova and Expenses (in $) of Singapore?
Keep it short and to the point. -9.96e+09. In the year 2009, what is the difference between the Expenses (in $) in Moldova and Expenses (in $) in South Africa?
Offer a terse response. -9.55e+1. In the year 2009, what is the difference between the Expenses (in $) in Singapore and Expenses (in $) in South Africa?
Your answer should be very brief. -8.55e+1. In the year 2010, what is the difference between the Expenses (in $) of Kuwait and Expenses (in $) of Moldova?
Offer a very short reply. -3.11e+09. In the year 2010, what is the difference between the Expenses (in $) of Kuwait and Expenses (in $) of Singapore?
Offer a very short reply. -1.26e+1. In the year 2010, what is the difference between the Expenses (in $) of Kuwait and Expenses (in $) of South Africa?
Keep it short and to the point. -1.09e+11. In the year 2010, what is the difference between the Expenses (in $) of Moldova and Expenses (in $) of Singapore?
Offer a terse response. -9.48e+09. In the year 2010, what is the difference between the Expenses (in $) of Moldova and Expenses (in $) of South Africa?
Your response must be concise. -1.06e+11. In the year 2010, what is the difference between the Expenses (in $) of Singapore and Expenses (in $) of South Africa?
Give a very brief answer. -9.69e+1. In the year 2011, what is the difference between the Expenses (in $) of Kuwait and Expenses (in $) of Moldova?
Make the answer very short. -3.50e+09. In the year 2011, what is the difference between the Expenses (in $) in Kuwait and Expenses (in $) in Singapore?
Ensure brevity in your answer.  -1.24e+1. In the year 2011, what is the difference between the Expenses (in $) in Kuwait and Expenses (in $) in South Africa?
Provide a short and direct response. -1.32e+11. In the year 2011, what is the difference between the Expenses (in $) in Moldova and Expenses (in $) in Singapore?
Keep it short and to the point. -8.94e+09. In the year 2011, what is the difference between the Expenses (in $) in Moldova and Expenses (in $) in South Africa?
Make the answer very short. -1.29e+11. In the year 2011, what is the difference between the Expenses (in $) of Singapore and Expenses (in $) of South Africa?
Your answer should be very brief. -1.20e+11. In the year 2012, what is the difference between the Expenses (in $) of Kuwait and Expenses (in $) of Moldova?
Your answer should be very brief. -3.69e+09. In the year 2012, what is the difference between the Expenses (in $) of Kuwait and Expenses (in $) of Singapore?
Your answer should be compact. -1.23e+1. In the year 2012, what is the difference between the Expenses (in $) in Kuwait and Expenses (in $) in South Africa?
Keep it short and to the point. -1.24e+11. In the year 2012, what is the difference between the Expenses (in $) of Moldova and Expenses (in $) of Singapore?
Ensure brevity in your answer.  -8.65e+09. In the year 2012, what is the difference between the Expenses (in $) in Moldova and Expenses (in $) in South Africa?
Your answer should be very brief. -1.20e+11. In the year 2012, what is the difference between the Expenses (in $) in Singapore and Expenses (in $) in South Africa?
Keep it short and to the point. -1.12e+11. What is the ratio of the Expenses (in $) in Kuwait in 2005 to that in 2006?
Give a very brief answer. 0.92. What is the ratio of the Expenses (in $) of Moldova in 2005 to that in 2006?
Keep it short and to the point. 0.72. What is the ratio of the Expenses (in $) in Singapore in 2005 to that in 2006?
Provide a succinct answer. 0.95. What is the ratio of the Expenses (in $) in South Africa in 2005 to that in 2006?
Your answer should be very brief. 0.98. What is the ratio of the Expenses (in $) in Kuwait in 2005 to that in 2007?
Provide a succinct answer. 0.81. What is the ratio of the Expenses (in $) in Moldova in 2005 to that in 2007?
Offer a very short reply. 0.61. What is the ratio of the Expenses (in $) of Singapore in 2005 to that in 2007?
Make the answer very short. 0.74. What is the ratio of the Expenses (in $) in South Africa in 2005 to that in 2007?
Provide a short and direct response. 0.83. What is the ratio of the Expenses (in $) of Kuwait in 2005 to that in 2008?
Keep it short and to the point. 0.75. What is the ratio of the Expenses (in $) of Moldova in 2005 to that in 2008?
Keep it short and to the point. 0.48. What is the ratio of the Expenses (in $) of Singapore in 2005 to that in 2008?
Your response must be concise. 0.67. What is the ratio of the Expenses (in $) of South Africa in 2005 to that in 2008?
Give a very brief answer. 0.67. What is the ratio of the Expenses (in $) of Kuwait in 2005 to that in 2009?
Give a very brief answer. 0.74. What is the ratio of the Expenses (in $) in Moldova in 2005 to that in 2009?
Provide a succinct answer. 0.44. What is the ratio of the Expenses (in $) in Singapore in 2005 to that in 2009?
Provide a succinct answer. 0.74. What is the ratio of the Expenses (in $) of South Africa in 2005 to that in 2009?
Give a very brief answer. 0.56. What is the ratio of the Expenses (in $) in Kuwait in 2005 to that in 2010?
Your answer should be very brief. 0.7. What is the ratio of the Expenses (in $) of Moldova in 2005 to that in 2010?
Keep it short and to the point. 0.38. What is the ratio of the Expenses (in $) of Singapore in 2005 to that in 2010?
Your answer should be very brief. 0.73. What is the ratio of the Expenses (in $) of South Africa in 2005 to that in 2010?
Provide a succinct answer. 0.51. What is the ratio of the Expenses (in $) in Kuwait in 2005 to that in 2011?
Your answer should be very brief. 0.63. What is the ratio of the Expenses (in $) in Moldova in 2005 to that in 2011?
Keep it short and to the point. 0.34. What is the ratio of the Expenses (in $) of Singapore in 2005 to that in 2011?
Keep it short and to the point. 0.73. What is the ratio of the Expenses (in $) in South Africa in 2005 to that in 2011?
Your answer should be very brief. 0.42. What is the ratio of the Expenses (in $) in Kuwait in 2005 to that in 2012?
Your response must be concise. 0.53. What is the ratio of the Expenses (in $) in Moldova in 2005 to that in 2012?
Your answer should be very brief. 0.31. What is the ratio of the Expenses (in $) of Singapore in 2005 to that in 2012?
Make the answer very short. 0.71. What is the ratio of the Expenses (in $) in South Africa in 2005 to that in 2012?
Your response must be concise. 0.45. What is the ratio of the Expenses (in $) in Kuwait in 2006 to that in 2007?
Your answer should be compact. 0.89. What is the ratio of the Expenses (in $) in Moldova in 2006 to that in 2007?
Provide a succinct answer. 0.86. What is the ratio of the Expenses (in $) of Singapore in 2006 to that in 2007?
Give a very brief answer. 0.77. What is the ratio of the Expenses (in $) in South Africa in 2006 to that in 2007?
Provide a short and direct response. 0.84. What is the ratio of the Expenses (in $) in Kuwait in 2006 to that in 2008?
Provide a succinct answer. 0.82. What is the ratio of the Expenses (in $) in Moldova in 2006 to that in 2008?
Your response must be concise. 0.67. What is the ratio of the Expenses (in $) of Singapore in 2006 to that in 2008?
Offer a very short reply. 0.71. What is the ratio of the Expenses (in $) of South Africa in 2006 to that in 2008?
Provide a succinct answer. 0.69. What is the ratio of the Expenses (in $) of Kuwait in 2006 to that in 2009?
Keep it short and to the point. 0.81. What is the ratio of the Expenses (in $) in Moldova in 2006 to that in 2009?
Offer a terse response. 0.61. What is the ratio of the Expenses (in $) in Singapore in 2006 to that in 2009?
Provide a short and direct response. 0.78. What is the ratio of the Expenses (in $) of South Africa in 2006 to that in 2009?
Your answer should be compact. 0.57. What is the ratio of the Expenses (in $) of Kuwait in 2006 to that in 2010?
Your answer should be compact. 0.77. What is the ratio of the Expenses (in $) of Moldova in 2006 to that in 2010?
Your response must be concise. 0.54. What is the ratio of the Expenses (in $) of Singapore in 2006 to that in 2010?
Ensure brevity in your answer.  0.77. What is the ratio of the Expenses (in $) of South Africa in 2006 to that in 2010?
Make the answer very short. 0.51. What is the ratio of the Expenses (in $) in Kuwait in 2006 to that in 2011?
Make the answer very short. 0.69. What is the ratio of the Expenses (in $) in Moldova in 2006 to that in 2011?
Your answer should be compact. 0.48. What is the ratio of the Expenses (in $) in Singapore in 2006 to that in 2011?
Offer a terse response. 0.77. What is the ratio of the Expenses (in $) of South Africa in 2006 to that in 2011?
Keep it short and to the point. 0.43. What is the ratio of the Expenses (in $) of Kuwait in 2006 to that in 2012?
Keep it short and to the point. 0.57. What is the ratio of the Expenses (in $) in Moldova in 2006 to that in 2012?
Provide a short and direct response. 0.43. What is the ratio of the Expenses (in $) in Singapore in 2006 to that in 2012?
Offer a terse response. 0.75. What is the ratio of the Expenses (in $) in South Africa in 2006 to that in 2012?
Offer a terse response. 0.45. What is the ratio of the Expenses (in $) of Kuwait in 2007 to that in 2008?
Provide a short and direct response. 0.93. What is the ratio of the Expenses (in $) in Moldova in 2007 to that in 2008?
Your answer should be compact. 0.78. What is the ratio of the Expenses (in $) in Singapore in 2007 to that in 2008?
Your response must be concise. 0.91. What is the ratio of the Expenses (in $) of South Africa in 2007 to that in 2008?
Offer a very short reply. 0.82. What is the ratio of the Expenses (in $) of Kuwait in 2007 to that in 2009?
Give a very brief answer. 0.91. What is the ratio of the Expenses (in $) of Moldova in 2007 to that in 2009?
Provide a short and direct response. 0.71. What is the ratio of the Expenses (in $) in South Africa in 2007 to that in 2009?
Keep it short and to the point. 0.68. What is the ratio of the Expenses (in $) of Kuwait in 2007 to that in 2010?
Offer a very short reply. 0.86. What is the ratio of the Expenses (in $) of Moldova in 2007 to that in 2010?
Your response must be concise. 0.63. What is the ratio of the Expenses (in $) in Singapore in 2007 to that in 2010?
Your answer should be very brief. 0.99. What is the ratio of the Expenses (in $) of South Africa in 2007 to that in 2010?
Ensure brevity in your answer.  0.61. What is the ratio of the Expenses (in $) of Kuwait in 2007 to that in 2011?
Offer a terse response. 0.78. What is the ratio of the Expenses (in $) in Moldova in 2007 to that in 2011?
Your answer should be compact. 0.56. What is the ratio of the Expenses (in $) of Singapore in 2007 to that in 2011?
Ensure brevity in your answer.  0.99. What is the ratio of the Expenses (in $) of South Africa in 2007 to that in 2011?
Give a very brief answer. 0.51. What is the ratio of the Expenses (in $) in Kuwait in 2007 to that in 2012?
Offer a very short reply. 0.65. What is the ratio of the Expenses (in $) of Moldova in 2007 to that in 2012?
Give a very brief answer. 0.5. What is the ratio of the Expenses (in $) in Singapore in 2007 to that in 2012?
Make the answer very short. 0.97. What is the ratio of the Expenses (in $) in South Africa in 2007 to that in 2012?
Provide a short and direct response. 0.54. What is the ratio of the Expenses (in $) of Kuwait in 2008 to that in 2009?
Keep it short and to the point. 0.98. What is the ratio of the Expenses (in $) of Moldova in 2008 to that in 2009?
Provide a succinct answer. 0.91. What is the ratio of the Expenses (in $) of Singapore in 2008 to that in 2009?
Make the answer very short. 1.1. What is the ratio of the Expenses (in $) in South Africa in 2008 to that in 2009?
Your response must be concise. 0.84. What is the ratio of the Expenses (in $) of Kuwait in 2008 to that in 2010?
Ensure brevity in your answer.  0.93. What is the ratio of the Expenses (in $) of Moldova in 2008 to that in 2010?
Give a very brief answer. 0.8. What is the ratio of the Expenses (in $) in Singapore in 2008 to that in 2010?
Your answer should be compact. 1.09. What is the ratio of the Expenses (in $) in South Africa in 2008 to that in 2010?
Provide a succinct answer. 0.75. What is the ratio of the Expenses (in $) in Kuwait in 2008 to that in 2011?
Provide a short and direct response. 0.84. What is the ratio of the Expenses (in $) of Moldova in 2008 to that in 2011?
Keep it short and to the point. 0.71. What is the ratio of the Expenses (in $) in Singapore in 2008 to that in 2011?
Give a very brief answer. 1.08. What is the ratio of the Expenses (in $) in South Africa in 2008 to that in 2011?
Your answer should be compact. 0.62. What is the ratio of the Expenses (in $) in Kuwait in 2008 to that in 2012?
Your answer should be very brief. 0.7. What is the ratio of the Expenses (in $) of Moldova in 2008 to that in 2012?
Give a very brief answer. 0.64. What is the ratio of the Expenses (in $) of Singapore in 2008 to that in 2012?
Make the answer very short. 1.06. What is the ratio of the Expenses (in $) in South Africa in 2008 to that in 2012?
Offer a terse response. 0.66. What is the ratio of the Expenses (in $) of Kuwait in 2009 to that in 2010?
Offer a terse response. 0.95. What is the ratio of the Expenses (in $) of Moldova in 2009 to that in 2010?
Your answer should be compact. 0.88. What is the ratio of the Expenses (in $) in South Africa in 2009 to that in 2010?
Your response must be concise. 0.9. What is the ratio of the Expenses (in $) of Kuwait in 2009 to that in 2011?
Your answer should be compact. 0.86. What is the ratio of the Expenses (in $) of Moldova in 2009 to that in 2011?
Your answer should be very brief. 0.78. What is the ratio of the Expenses (in $) in Singapore in 2009 to that in 2011?
Offer a very short reply. 0.99. What is the ratio of the Expenses (in $) in South Africa in 2009 to that in 2011?
Provide a succinct answer. 0.74. What is the ratio of the Expenses (in $) of Kuwait in 2009 to that in 2012?
Ensure brevity in your answer.  0.71. What is the ratio of the Expenses (in $) of Moldova in 2009 to that in 2012?
Keep it short and to the point. 0.7. What is the ratio of the Expenses (in $) in Singapore in 2009 to that in 2012?
Give a very brief answer. 0.96. What is the ratio of the Expenses (in $) in South Africa in 2009 to that in 2012?
Your answer should be compact. 0.79. What is the ratio of the Expenses (in $) of Kuwait in 2010 to that in 2011?
Your answer should be compact. 0.9. What is the ratio of the Expenses (in $) of Moldova in 2010 to that in 2011?
Provide a short and direct response. 0.89. What is the ratio of the Expenses (in $) in Singapore in 2010 to that in 2011?
Offer a very short reply. 1. What is the ratio of the Expenses (in $) of South Africa in 2010 to that in 2011?
Offer a terse response. 0.83. What is the ratio of the Expenses (in $) of Kuwait in 2010 to that in 2012?
Your answer should be compact. 0.75. What is the ratio of the Expenses (in $) in Moldova in 2010 to that in 2012?
Ensure brevity in your answer.  0.81. What is the ratio of the Expenses (in $) of South Africa in 2010 to that in 2012?
Your answer should be compact. 0.88. What is the ratio of the Expenses (in $) of Kuwait in 2011 to that in 2012?
Your response must be concise. 0.83. What is the ratio of the Expenses (in $) of Moldova in 2011 to that in 2012?
Your response must be concise. 0.9. What is the ratio of the Expenses (in $) in Singapore in 2011 to that in 2012?
Keep it short and to the point. 0.98. What is the ratio of the Expenses (in $) of South Africa in 2011 to that in 2012?
Provide a succinct answer. 1.06. What is the difference between the highest and the second highest Expenses (in $) in Kuwait?
Provide a short and direct response. 4.33e+08. What is the difference between the highest and the second highest Expenses (in $) of Moldova?
Offer a terse response. 6.26e+08. What is the difference between the highest and the second highest Expenses (in $) of Singapore?
Keep it short and to the point. 8.91e+08. What is the difference between the highest and the second highest Expenses (in $) of South Africa?
Make the answer very short. 8.03e+09. What is the difference between the highest and the lowest Expenses (in $) in Kuwait?
Make the answer very short. 1.21e+09. What is the difference between the highest and the lowest Expenses (in $) of Moldova?
Your answer should be very brief. 4.32e+09. What is the difference between the highest and the lowest Expenses (in $) in Singapore?
Your answer should be compact. 5.19e+09. What is the difference between the highest and the lowest Expenses (in $) in South Africa?
Make the answer very short. 7.82e+1. 